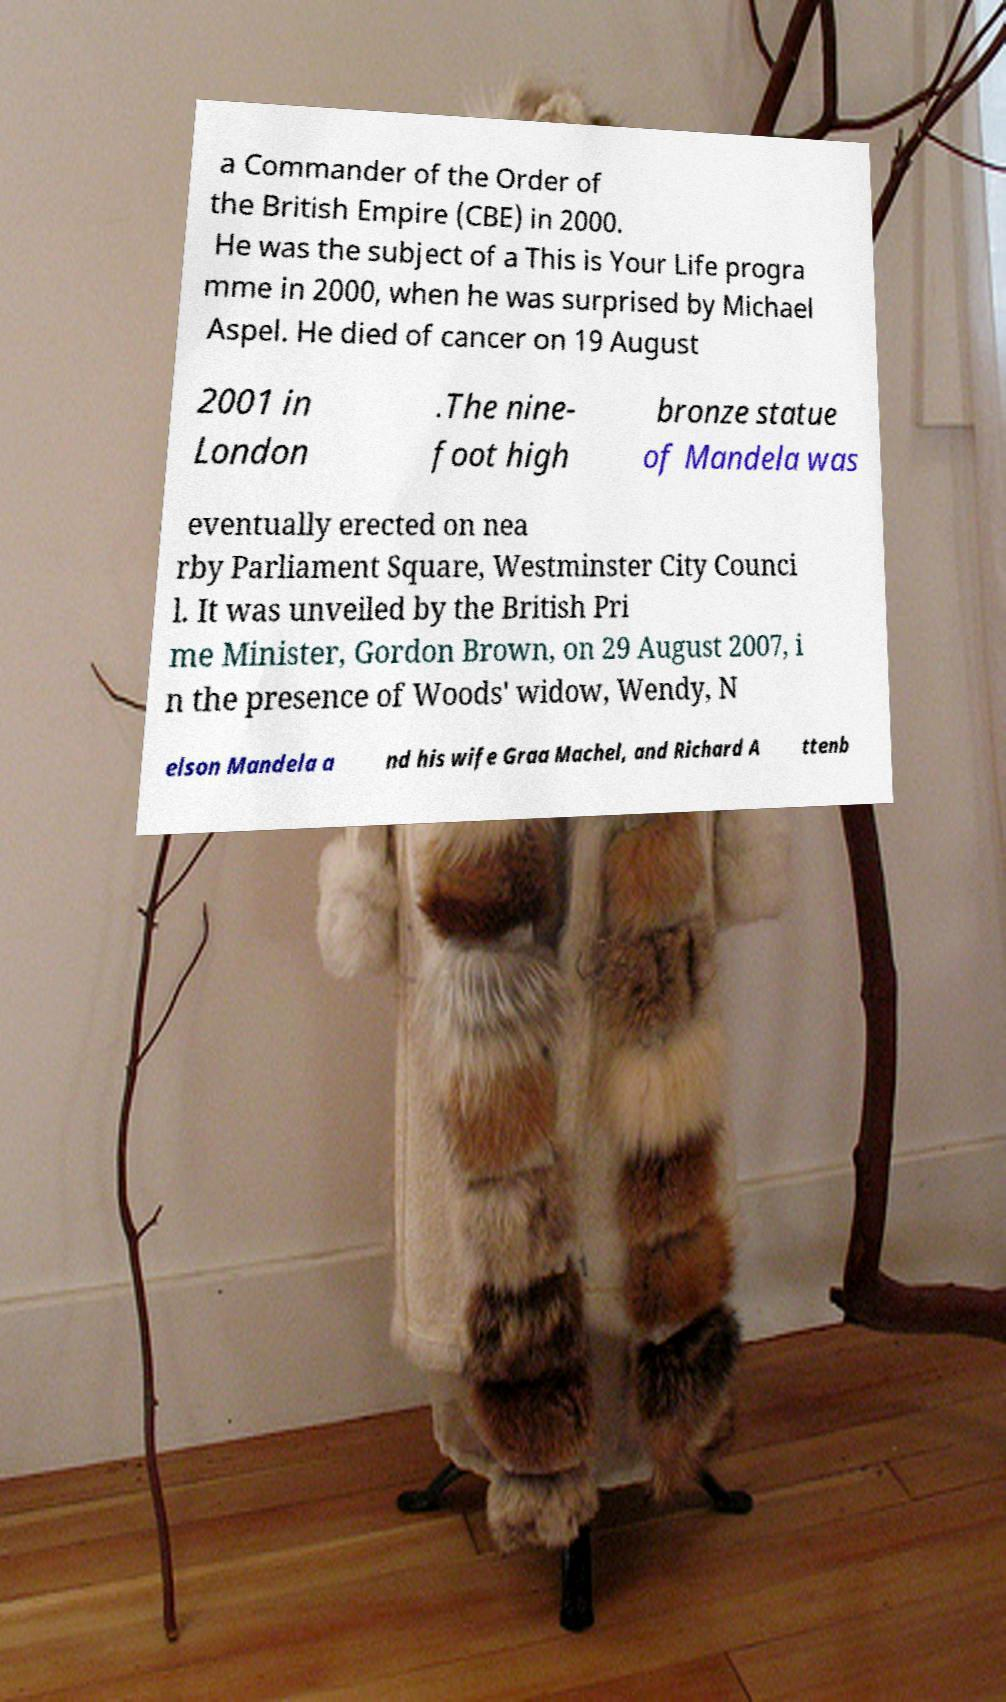Can you accurately transcribe the text from the provided image for me? a Commander of the Order of the British Empire (CBE) in 2000. He was the subject of a This is Your Life progra mme in 2000, when he was surprised by Michael Aspel. He died of cancer on 19 August 2001 in London .The nine- foot high bronze statue of Mandela was eventually erected on nea rby Parliament Square, Westminster City Counci l. It was unveiled by the British Pri me Minister, Gordon Brown, on 29 August 2007, i n the presence of Woods' widow, Wendy, N elson Mandela a nd his wife Graa Machel, and Richard A ttenb 